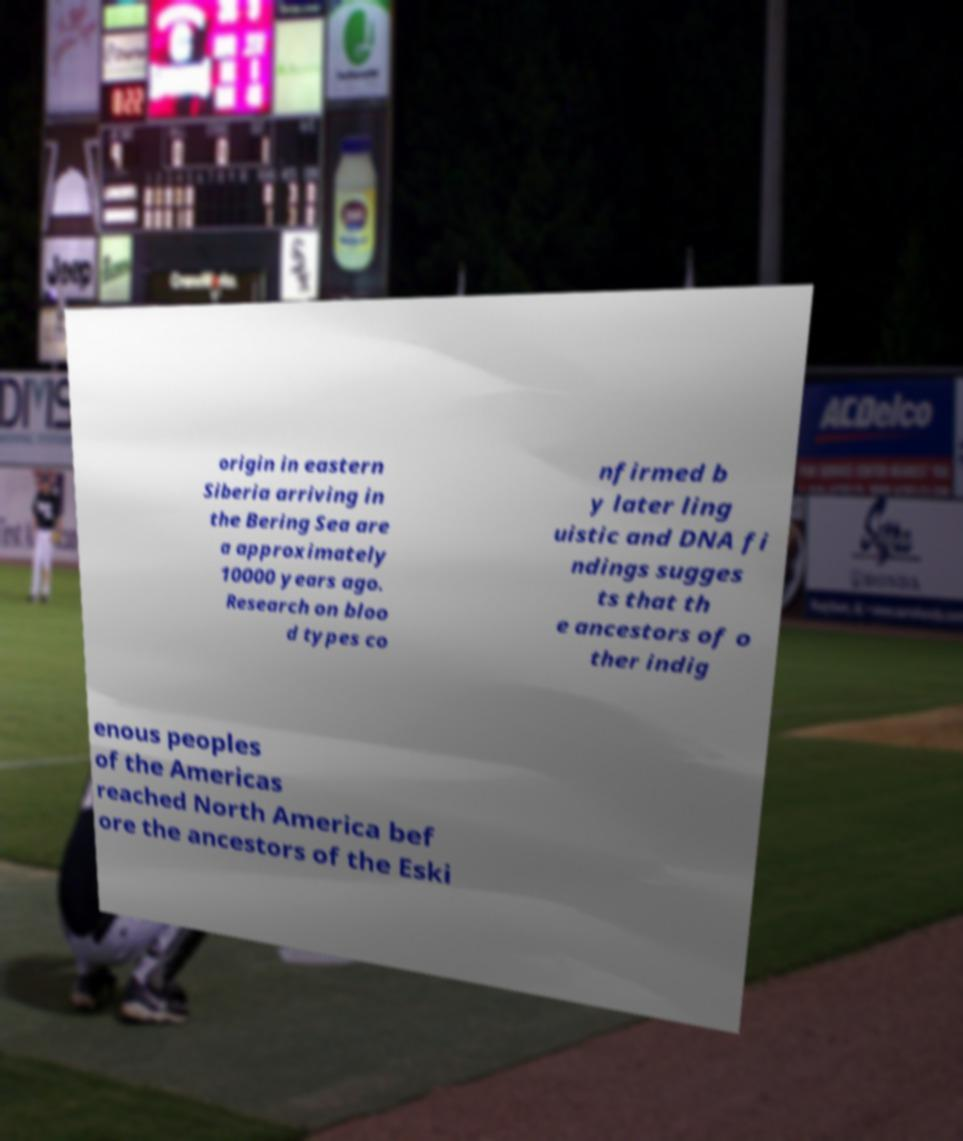I need the written content from this picture converted into text. Can you do that? origin in eastern Siberia arriving in the Bering Sea are a approximately 10000 years ago. Research on bloo d types co nfirmed b y later ling uistic and DNA fi ndings sugges ts that th e ancestors of o ther indig enous peoples of the Americas reached North America bef ore the ancestors of the Eski 